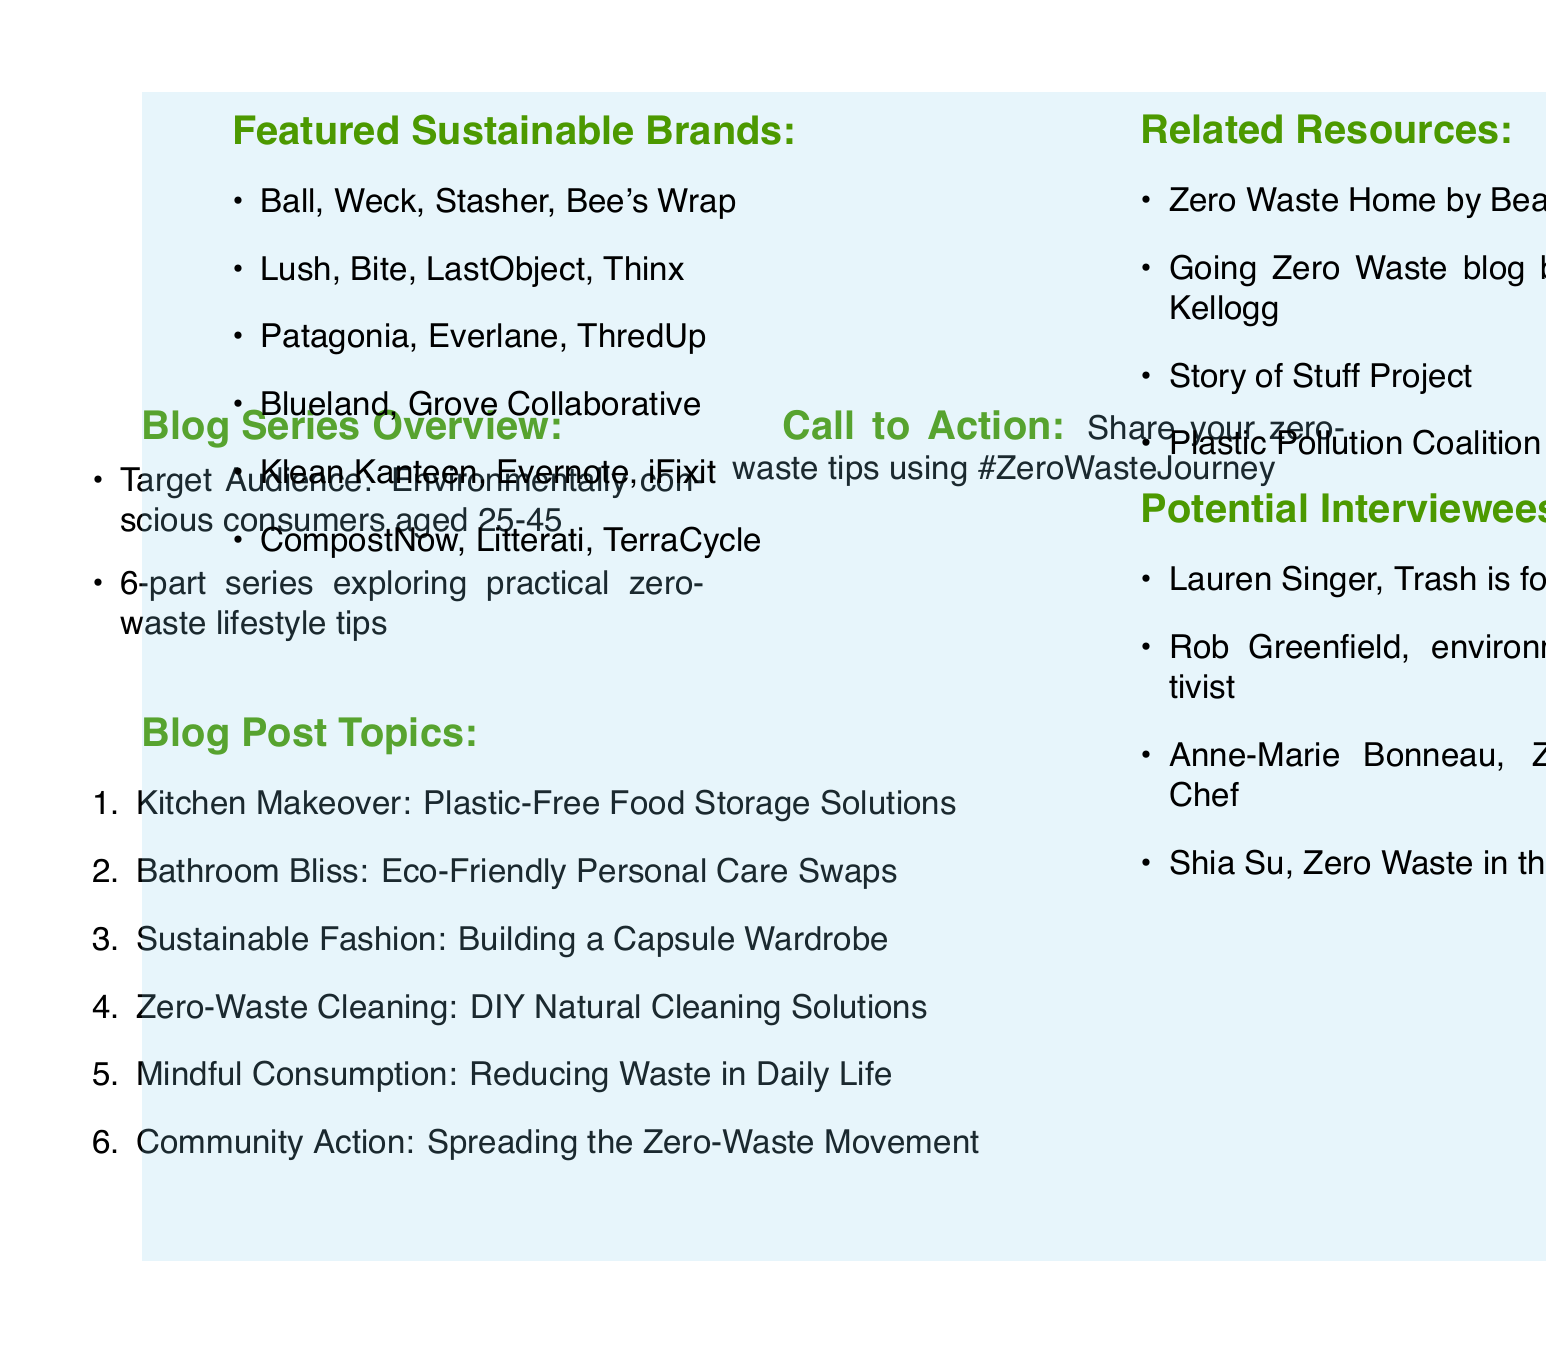What is the series title? The series title is explicitly mentioned at the top of the document as "Zero-Waste Living: Small Steps, Big Impact."
Answer: Zero-Waste Living: Small Steps, Big Impact How many blog posts are included in the series? The document lists six distinct blog posts that make up the series, as indicated in the blog post topics section.
Answer: 6 Which sustainable brand is mentioned in the bathroom blog post? The sustainable brands for the bathroom blog post are specifically listed, which includes Lush as one of them.
Answer: Lush What is the call to action for readers? The document encourages readers to share their own zero-waste tips using a specified hashtag, directly stating the call to action.
Answer: #ZeroWasteJourney What is one key point discussed under "Mindful Consumption"? The document outlines key points for each blog post, and one of them under "Mindful Consumption" is to carry a zero-waste kit.
Answer: Carrying a zero-waste kit Who is one potential interviewee featured in the document? The document includes several potential interviewees, among which Lauren Singer is explicitly mentioned.
Answer: Lauren Singer What type of audience is the series targeting? Target audience information is given, specifying the demographic characteristics of the intended readers for the series.
Answer: Environmentally conscious consumers aged 25-45 What is a featured sustainable brand in the kitchen blog post? The kitchen blog post lists several sustainable brands, including Ball as one of the featured options.
Answer: Ball What resource is recommended for readers interested in a zero-waste lifestyle? Among several related resources, "Zero Waste Home by Bea Johnson" is specifically recommended in the document.
Answer: Zero Waste Home by Bea Johnson 